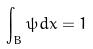Convert formula to latex. <formula><loc_0><loc_0><loc_500><loc_500>\int _ { B } \psi d x = 1</formula> 